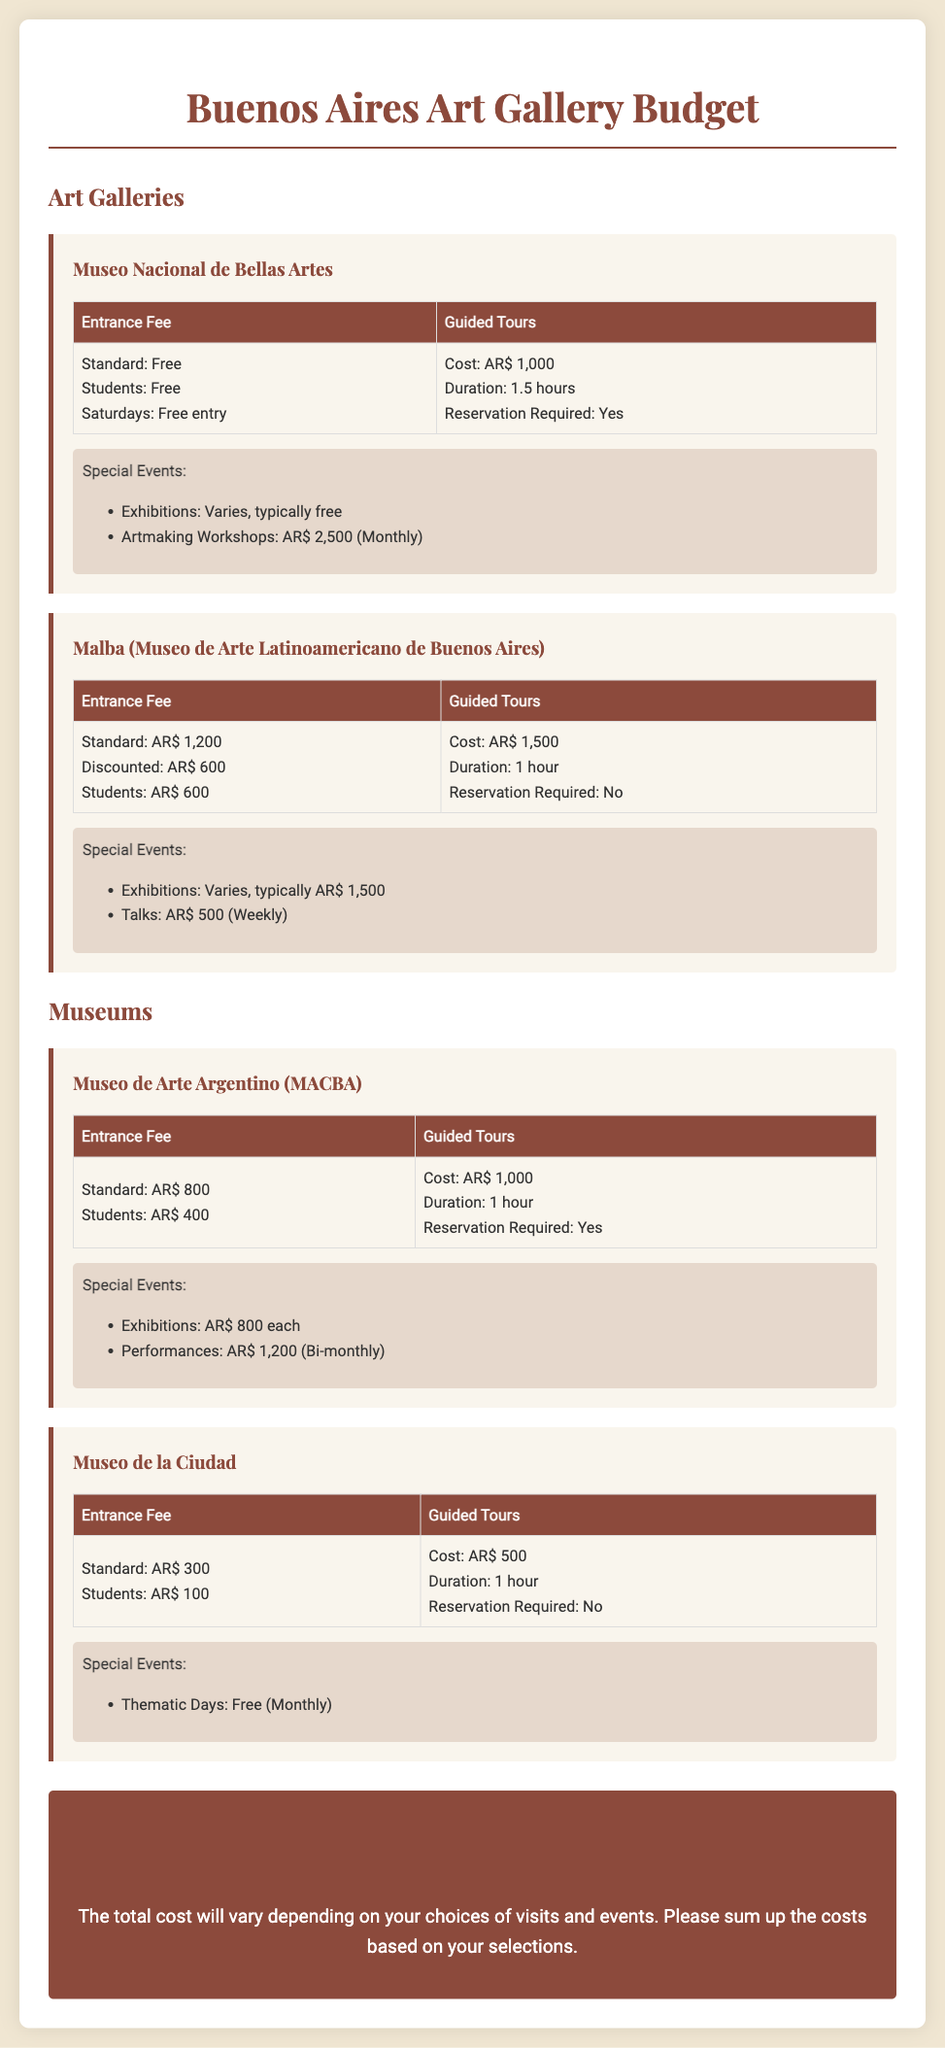what is the entrance fee for Museo Nacional de Bellas Artes? The entrance fee for Museo Nacional de Bellas Artes is listed as Free for standard and students, with free entry on Saturdays.
Answer: Free how much does a guided tour cost at Malba? The cost of a guided tour at Malba is stated in the document.
Answer: AR$ 1,500 what is the duration of guided tours at Museo de Arte Argentino (MACBA)? The document specifies the duration for guided tours at MACBA.
Answer: 1 hour how much is the entrance fee for students at Museo de la Ciudad? The entrance fee for students at Museo de la Ciudad is mentioned in the document.
Answer: AR$ 100 what is the cost of a monthly artmaking workshop at Museo Nacional de Bellas Artes? The cost of the monthly artmaking workshops is provided in the special events section of the document.
Answer: AR$ 2,500 which museum has free thematic days? The document indicates that Museo de la Ciudad has thematic days that are free.
Answer: Museo de la Ciudad how much would it cost to attend a performance at Museo de Arte Argentino (MACBA)? The cost for performances at MACBA is found in the special events section of the document.
Answer: AR$ 1,200 is reservation required for guided tours at Malba? The document states whether a reservation is needed for guided tours at Malba.
Answer: No 